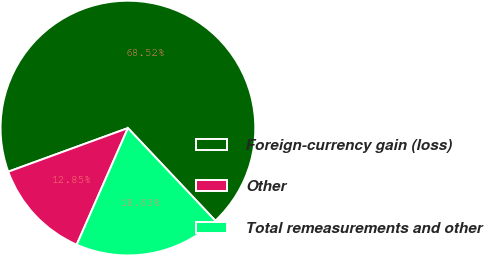<chart> <loc_0><loc_0><loc_500><loc_500><pie_chart><fcel>Foreign-currency gain (loss)<fcel>Other<fcel>Total remeasurements and other<nl><fcel>68.52%<fcel>12.85%<fcel>18.63%<nl></chart> 